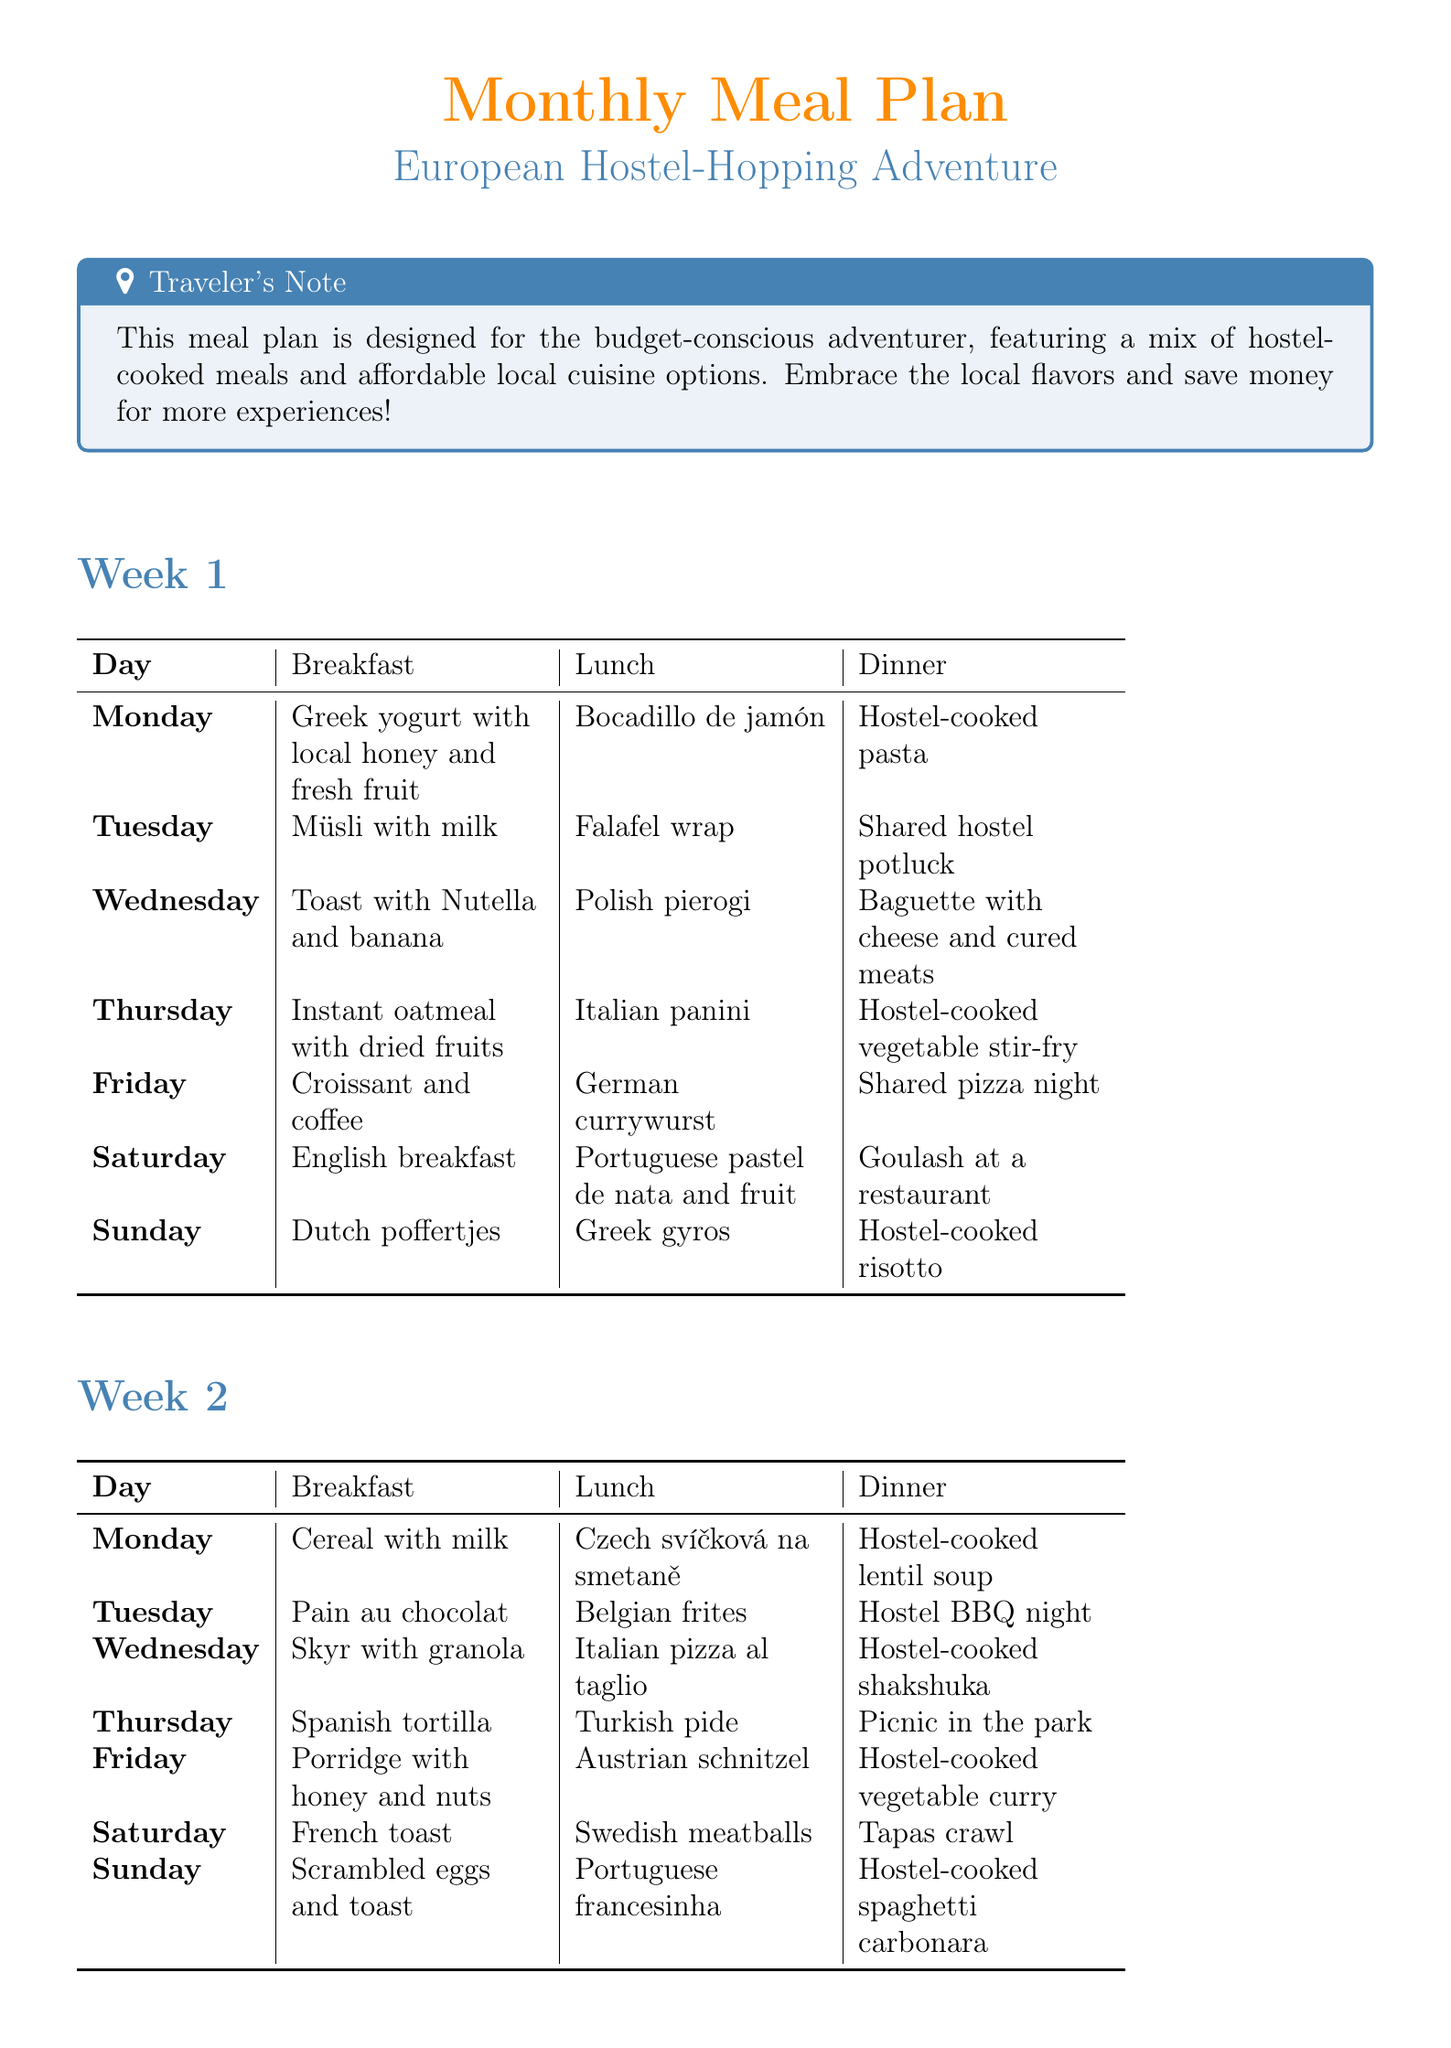What is the breakfast on Monday of Week 1? The breakfast on Monday of Week 1 is "Greek yogurt with local honey and fresh fruit from a market."
Answer: Greek yogurt with local honey and fresh fruit What is the dinner on Friday of Week 2? The dinner on Friday of Week 2 is "Hostel-cooked vegetable curry with rice."
Answer: Hostel-cooked vegetable curry with rice How many different meals are listed for Week 3? Each day of Week 3 has three meals and there are seven days, so the total is 21 meals.
Answer: 21 Which local dish is served for lunch on Sunday in Week 4? The lunch on Sunday in Week 4 is "Italian gelato and focaccia."
Answer: Italian gelato and focaccia What type of cuisine is emphasized in the meal plan? The plan highlights affordable local cuisine options while traveling.
Answer: Affordable local cuisine What meal requires participants to contribute at the hostel on Tuesday of Week 2? The meal that requires contribution on Tuesday of Week 2 is "Hostel BBQ night: contribute vegetables or sausages."
Answer: Hostel BBQ night: contribute vegetables or sausages How many weeks does the meal plan cover? The meal plan covers four weeks.
Answer: Four What is the common theme of the meals included in the document? The common theme is budget-friendly meals suitable for travelers.
Answer: Budget-friendly meals suitable for travelers 